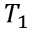Convert formula to latex. <formula><loc_0><loc_0><loc_500><loc_500>T _ { 1 }</formula> 